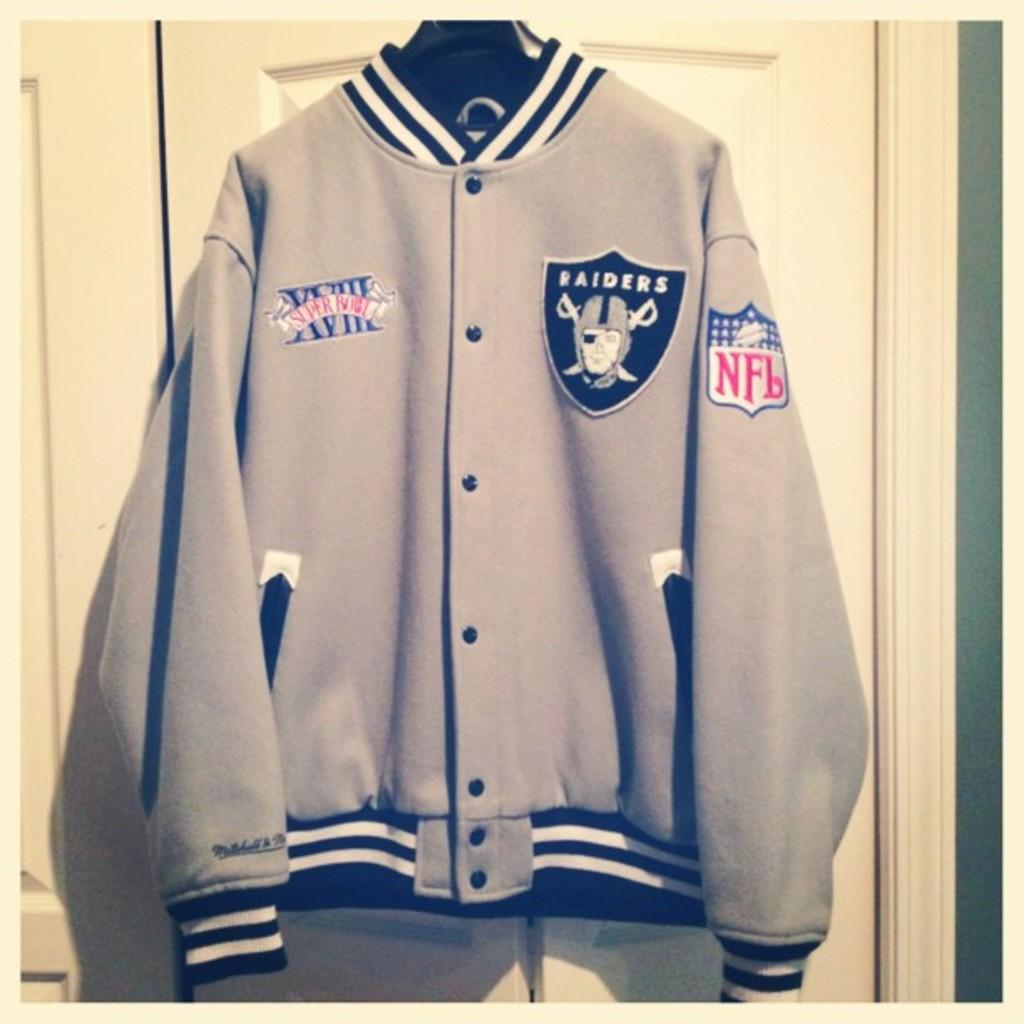<image>
Render a clear and concise summary of the photo. A jacket with a NFL and Raiders patch hangs on a door. 